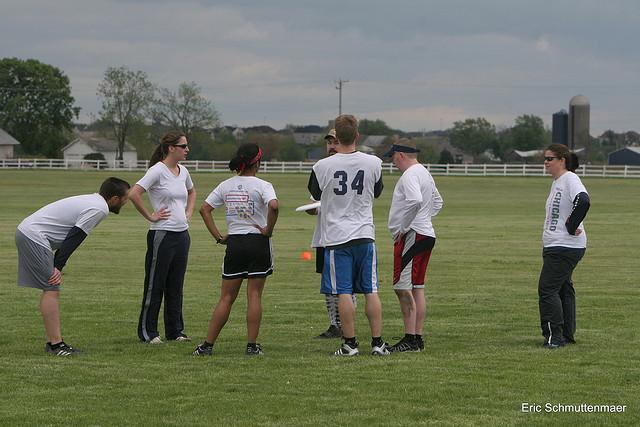How many people are shown?
Write a very short answer. 7. How many adults are present?
Write a very short answer. 7. What is the number of the player holding the frisbee?
Quick response, please. 34. What number is visible?
Keep it brief. 34. What are they two tall buildings in the background?
Be succinct. Silos. How many players have visible numbers?
Short answer required. 1. How many guys that are shirtless?
Short answer required. 0. What is the animal that is the mascot for the home team in this photo?
Short answer required. Bear. How many players are on the field?
Answer briefly. 7. How many players are there?
Give a very brief answer. 7. 